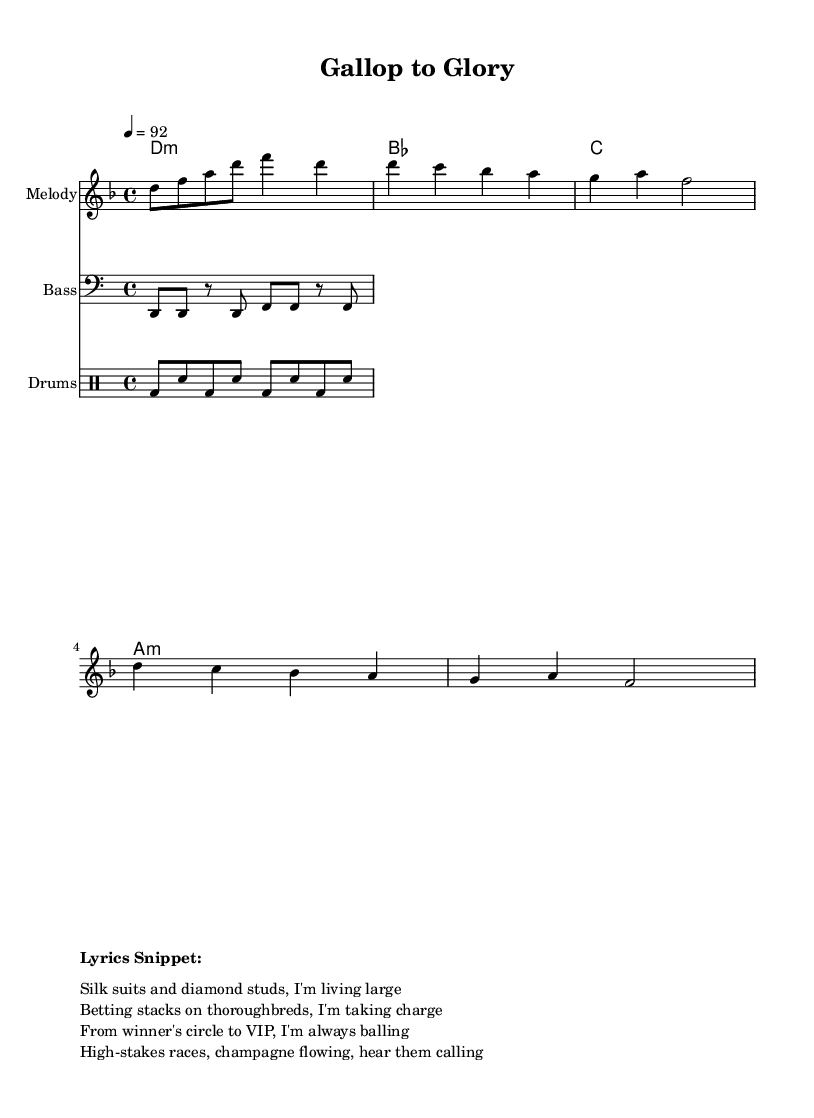What is the key signature of this music? The key signature is indicated by the absence of any sharps or flats on the staff. In this case, the notation shows that the music is in D minor, which has one flat (B flat).
Answer: D minor What is the time signature of the piece? The time signature is represented at the beginning of the score, where it indicates how many beats are in each measure. Here, 4/4 shows there are four beats per measure.
Answer: 4/4 What is the tempo marking for this piece? The tempo is noted with the instruction that states "4 = 92," indicating that there are 92 beats per minute. This provides the speed of the performance.
Answer: 92 How many times is the chorus repeated in the score? The chorus section of the melody is written to be repeated multiple times. Observing the repeated chords and melodic lines confirms that it appears twice as explicitly shown in the written section.
Answer: Twice What is the genre of the composition indicated by the lyrics? The lyrics reflect themes common to hip hop, including wealth and luxury, while also mentioning specific activities like horse racing. The combination of lifestyle references and rhythmic delivery aligns with hip hop characteristics.
Answer: Hip hop What instruments are featured in this score? The score outlines different staves for various instrumental parts: a melody staff for the lead, a bass staff for lower frequencies, and a drum staff for percussion, illustrating a multipurpose arrangement typical for hip hop productions.
Answer: Melody, Bass, Drums 